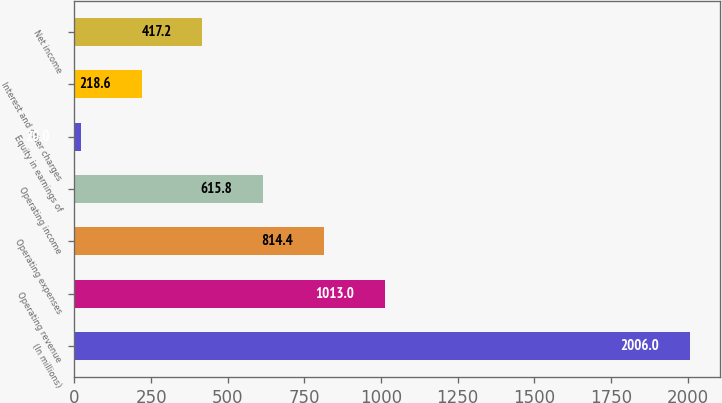Convert chart to OTSL. <chart><loc_0><loc_0><loc_500><loc_500><bar_chart><fcel>(In millions)<fcel>Operating revenue<fcel>Operating expenses<fcel>Operating income<fcel>Equity in earnings of<fcel>Interest and other charges<fcel>Net income<nl><fcel>2006<fcel>1013<fcel>814.4<fcel>615.8<fcel>20<fcel>218.6<fcel>417.2<nl></chart> 